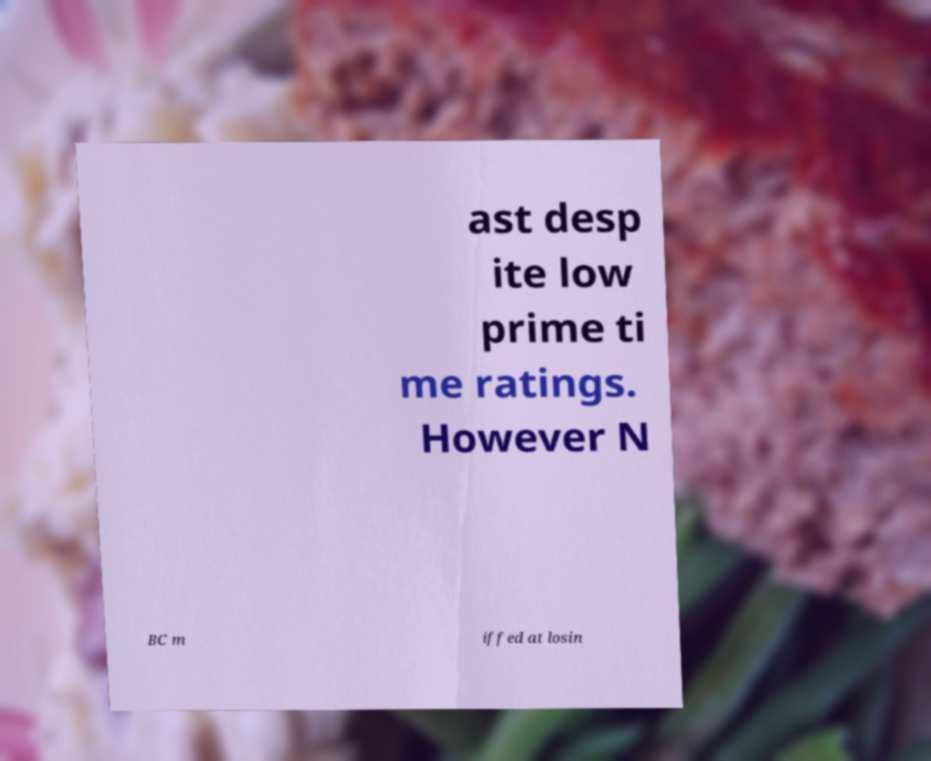Please identify and transcribe the text found in this image. ast desp ite low prime ti me ratings. However N BC m iffed at losin 